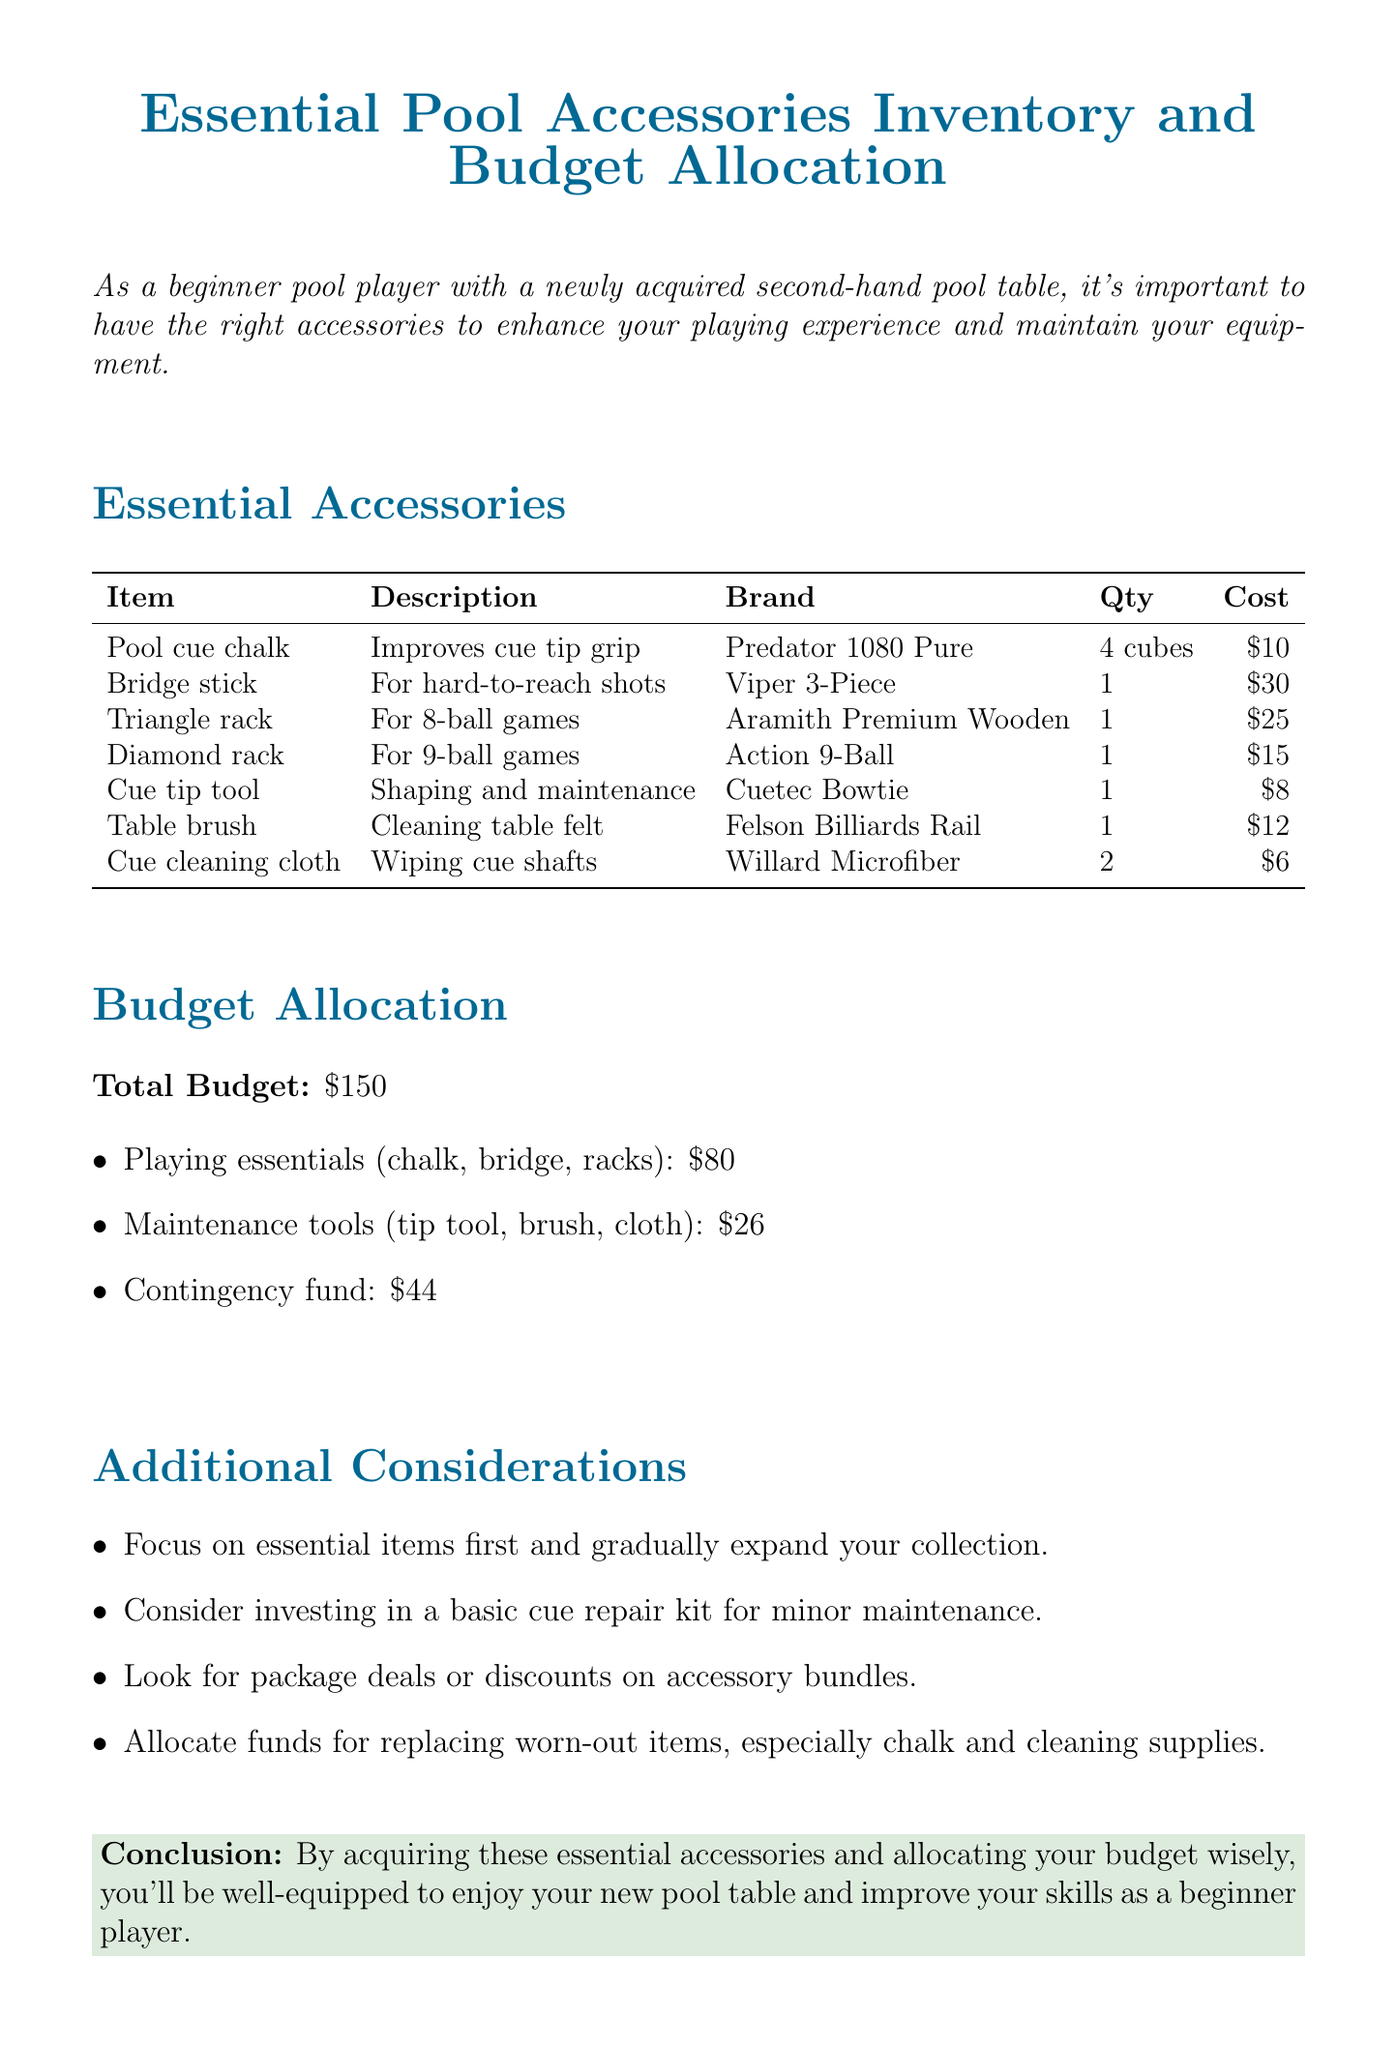What is the total budget allocated for pool accessories? The total budget is explicitly stated in the document as part of the budget allocation section.
Answer: $150 Which item is recommended for cleaning the table felt? The document lists the table brush as the accessory for cleaning the table felt under essential accessories.
Answer: Table brush How many cubes of pool cue chalk are recommended? The quantity for pool cue chalk is specified in the essential accessories table.
Answer: 4 cubes What is the allocated budget for playing essentials? Budget allocation details the specific amount set aside for playing essentials within the total budget.
Answer: $80 What type of rack is mentioned for 8-ball games? The triangle rack is identified in the list of essential accessories, specifically for 8-ball games.
Answer: Triangle rack Which brand of cue cleaning cloth is recommended? The recommended brand for cue cleaning cloth is explicitly stated in the essential accessories section.
Answer: Willard Microfiber What’s the purpose of the contingency fund? The document mentions that the contingency fund is for unexpected expenses or future upgrades in the budget allocation section.
Answer: Unexpected expenses What does the conclusion emphasize about your budget allocation? The conclusion ties back to the importance of wise budget allocation for improving skills as a beginner player.
Answer: Improve skills How many maintenance tools are listed in the memo? The document lists the maintenance tools under their respective category in the budget allocation section.
Answer: 3 